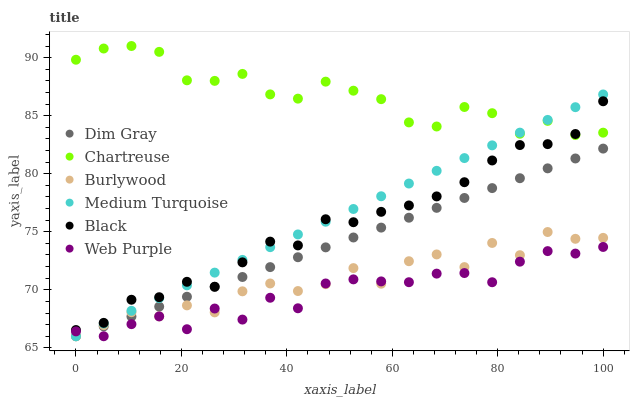Does Web Purple have the minimum area under the curve?
Answer yes or no. Yes. Does Chartreuse have the maximum area under the curve?
Answer yes or no. Yes. Does Burlywood have the minimum area under the curve?
Answer yes or no. No. Does Burlywood have the maximum area under the curve?
Answer yes or no. No. Is Dim Gray the smoothest?
Answer yes or no. Yes. Is Burlywood the roughest?
Answer yes or no. Yes. Is Web Purple the smoothest?
Answer yes or no. No. Is Web Purple the roughest?
Answer yes or no. No. Does Dim Gray have the lowest value?
Answer yes or no. Yes. Does Chartreuse have the lowest value?
Answer yes or no. No. Does Chartreuse have the highest value?
Answer yes or no. Yes. Does Burlywood have the highest value?
Answer yes or no. No. Is Burlywood less than Black?
Answer yes or no. Yes. Is Black greater than Dim Gray?
Answer yes or no. Yes. Does Medium Turquoise intersect Burlywood?
Answer yes or no. Yes. Is Medium Turquoise less than Burlywood?
Answer yes or no. No. Is Medium Turquoise greater than Burlywood?
Answer yes or no. No. Does Burlywood intersect Black?
Answer yes or no. No. 